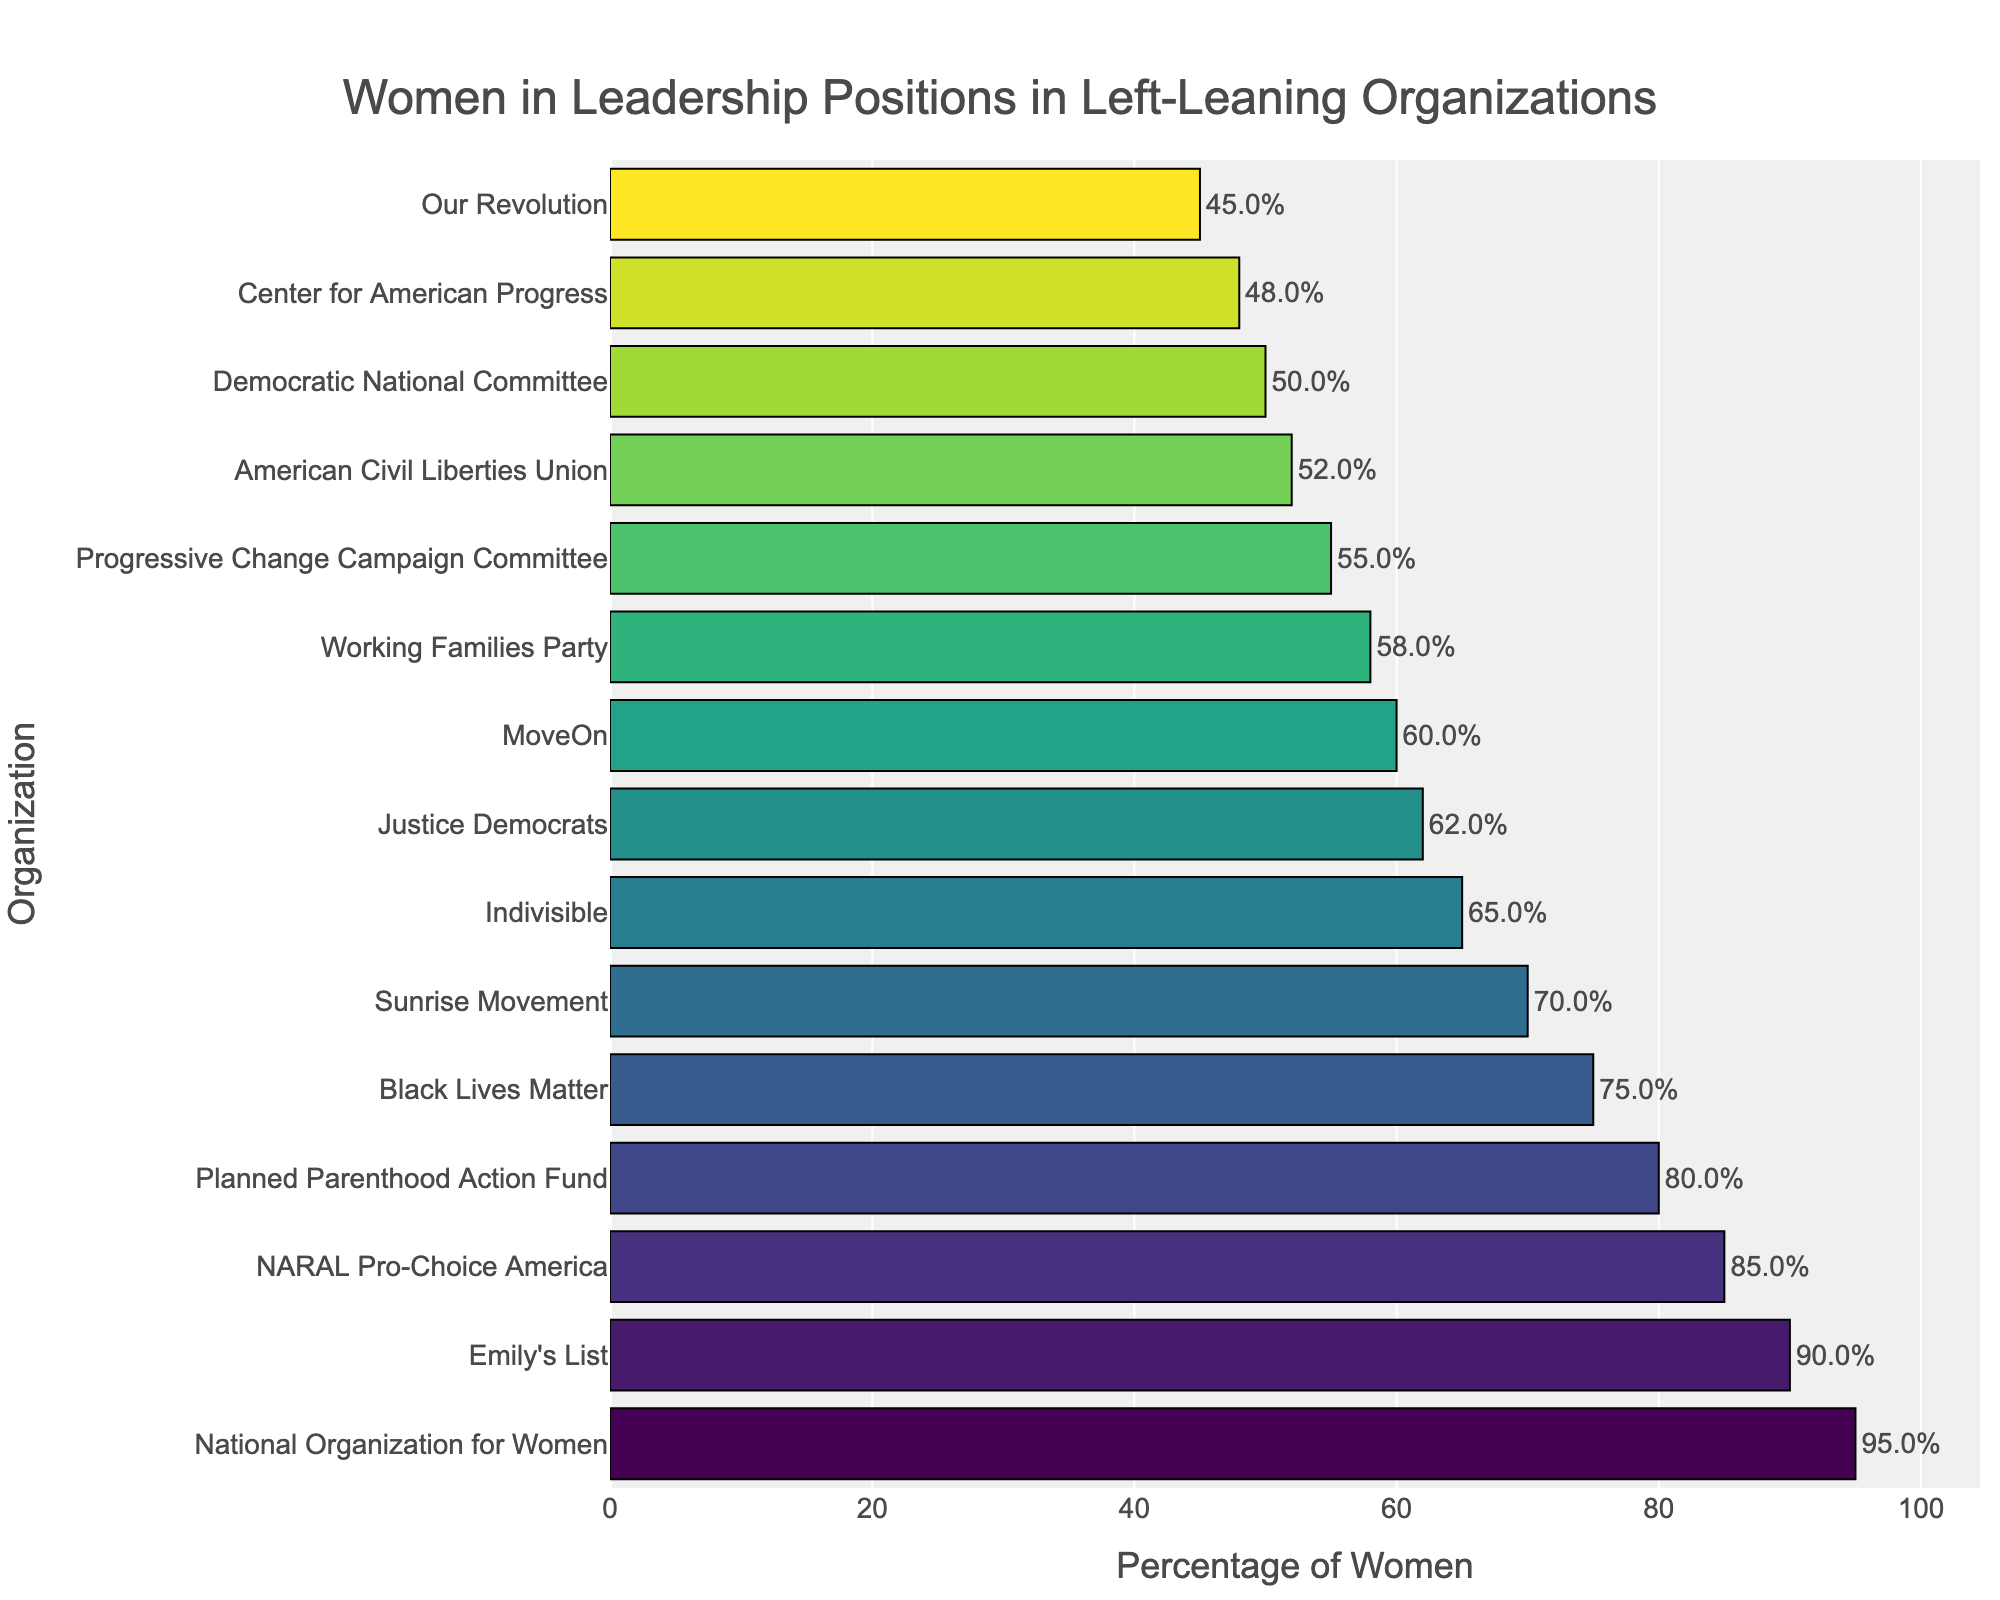What's the organization with the highest percentage of women in leadership positions? The highest bar represents the organization with the greatest percentage. The tallest bar corresponds to the National Organization for Women at 95%.
Answer: National Organization for Women Which organization has a slightly higher percentage of women in leadership compared to Democratic National Committee? Compare the percentages of surrounding organizations relative to the Democratic National Committee, which has 50%. The American Civil Liberties Union has 52%, which is slightly higher.
Answer: American Civil Liberties Union What's the difference in the percentage of women in leadership between Emily's List and Our Revolution? Emily's List has 90%, while Our Revolution has 45%. Subtract 45 from 90 to get the difference.
Answer: 45% What's the average percentage of women in leadership across the top three organizations with the highest percentages? The top three organizations are National Organization for Women (95%), NARAL Pro-Choice America (85%), and Planned Parenthood Action Fund (80%). The average is (95 + 85 + 80) / 3 = 86.67%.
Answer: 86.67% Which organizations have more than 70% but less than 90% of women in leadership? Identify the organizations with percentages between 70% and 90%: Sunrise Movement (70%), Black Lives Matter (75%), Planned Parenthood Action Fund (80%), and NARAL Pro-Choice America (85%).
Answer: Sunrise Movement, Black Lives Matter, Planned Parenthood Action Fund, NARAL Pro-Choice America What's the median percentage of women in leadership among all listed organizations? Sort the percentages and find the middle value. Sorted list: [45, 48, 50, 52, 55, 58, 60, 62, 65, 70, 75, 80, 85, 90, 95]. The median is the 8th value, which is 62%.
Answer: 62% How much higher is the percentage of women in leadership at NARAL Pro-Choice America compared to the Center for American Progress? Compare 85% (NARAL Pro-Choice America) to 48% (Center for American Progress). The difference is 85 - 48 = 37%.
Answer: 37% What visual trend can you observe about the color of the bars as the percentage increases? The colors move from darker to lighter shades, indicating a gradient effect as the percentage of women increases.
Answer: Darker to lighter shades Which organization has just above 65% but just below 75% of women in leadership? Move through the relevant values: Sunrise Movement (70%) fits the criteria.
Answer: Sunrise Movement 